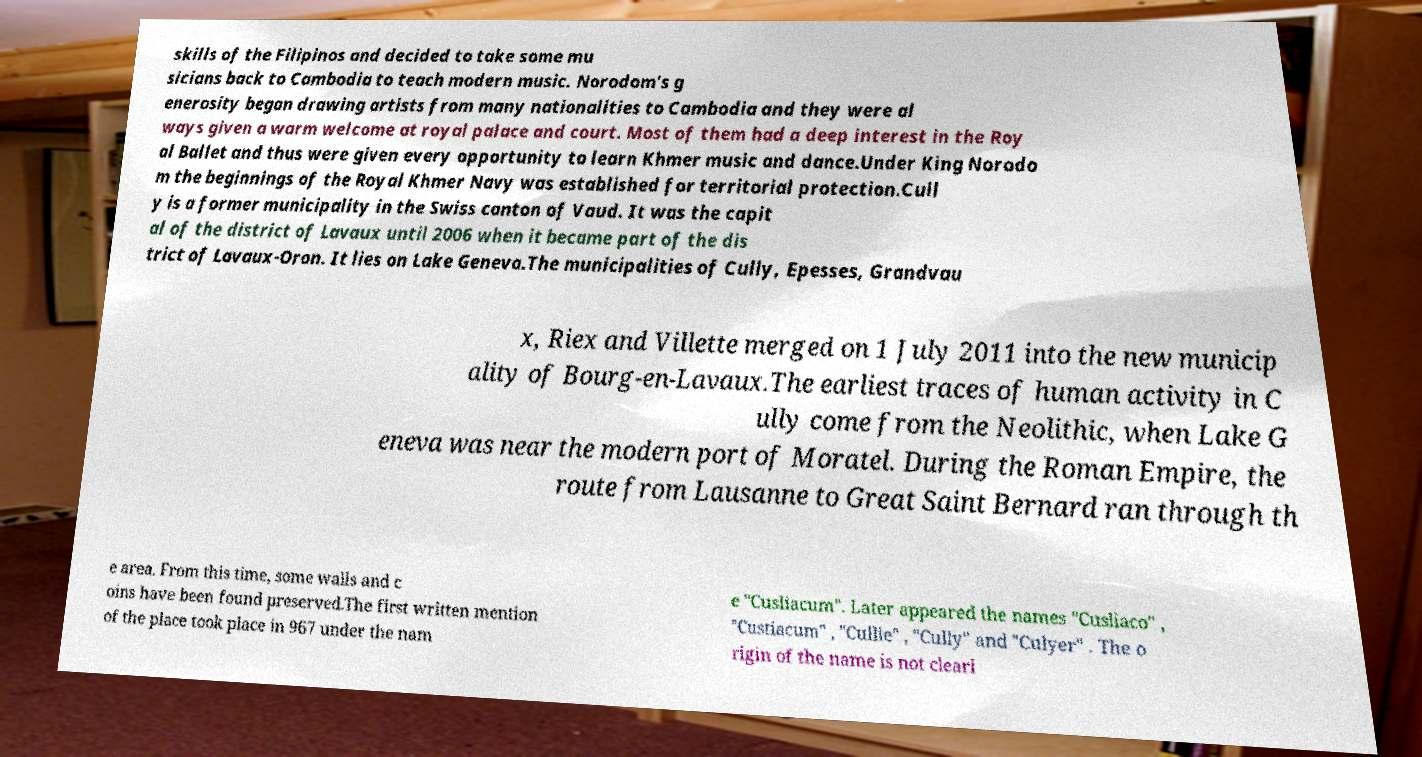Can you accurately transcribe the text from the provided image for me? skills of the Filipinos and decided to take some mu sicians back to Cambodia to teach modern music. Norodom's g enerosity began drawing artists from many nationalities to Cambodia and they were al ways given a warm welcome at royal palace and court. Most of them had a deep interest in the Roy al Ballet and thus were given every opportunity to learn Khmer music and dance.Under King Norodo m the beginnings of the Royal Khmer Navy was established for territorial protection.Cull y is a former municipality in the Swiss canton of Vaud. It was the capit al of the district of Lavaux until 2006 when it became part of the dis trict of Lavaux-Oron. It lies on Lake Geneva.The municipalities of Cully, Epesses, Grandvau x, Riex and Villette merged on 1 July 2011 into the new municip ality of Bourg-en-Lavaux.The earliest traces of human activity in C ully come from the Neolithic, when Lake G eneva was near the modern port of Moratel. During the Roman Empire, the route from Lausanne to Great Saint Bernard ran through th e area. From this time, some walls and c oins have been found preserved.The first written mention of the place took place in 967 under the nam e "Cusliacum". Later appeared the names "Cusliaco" , "Custiacum" , "Cullie" , "Cully" and "Culyer" . The o rigin of the name is not clearl 